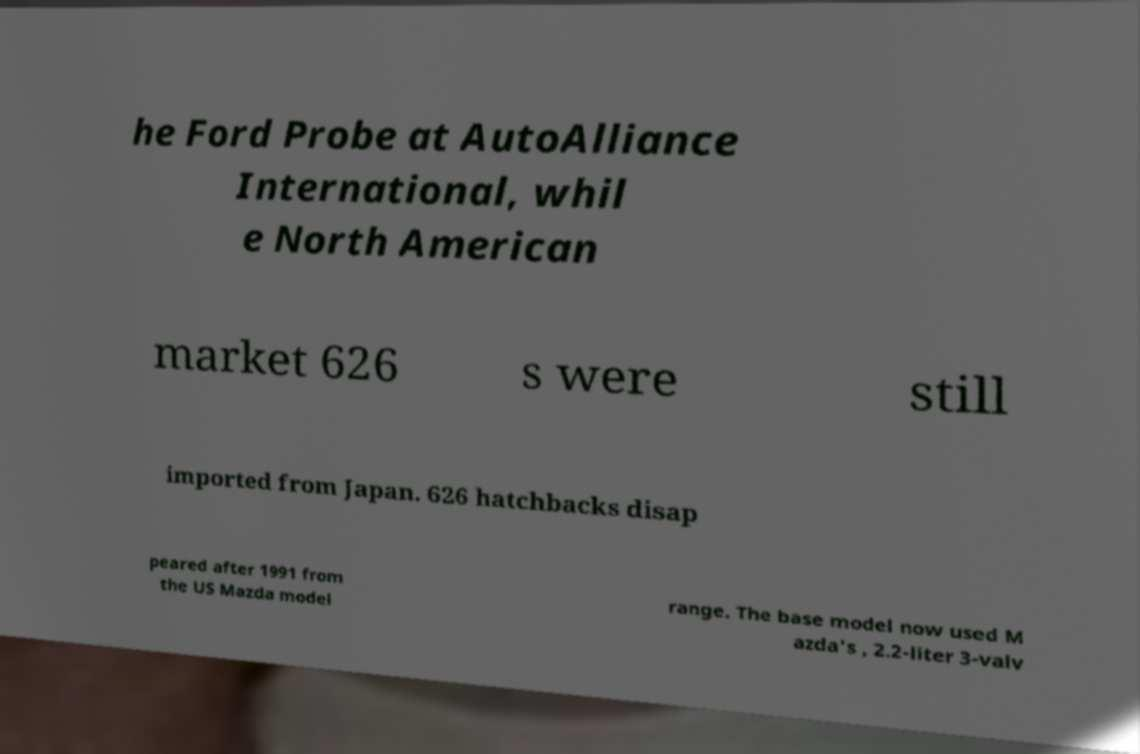What messages or text are displayed in this image? I need them in a readable, typed format. he Ford Probe at AutoAlliance International, whil e North American market 626 s were still imported from Japan. 626 hatchbacks disap peared after 1991 from the US Mazda model range. The base model now used M azda's , 2.2-liter 3-valv 